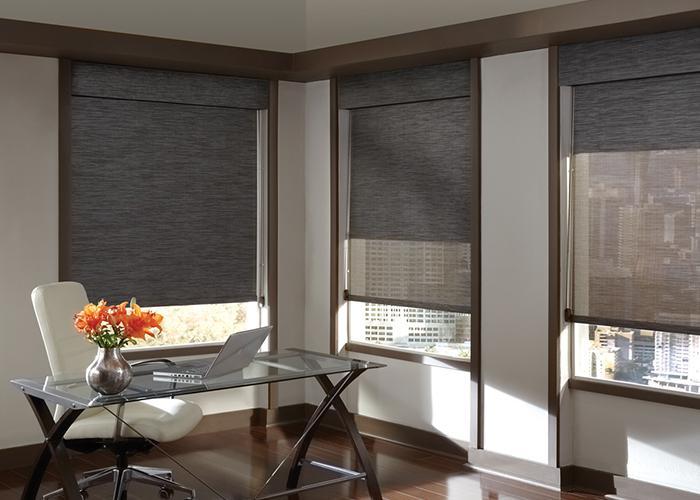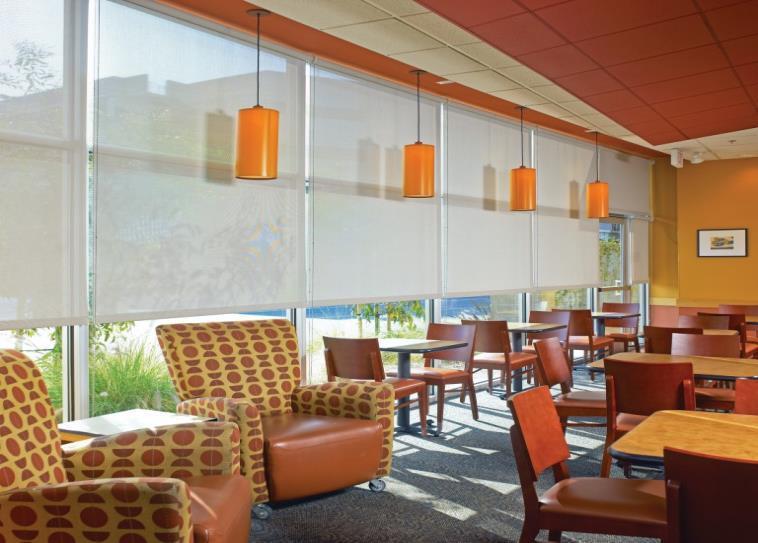The first image is the image on the left, the second image is the image on the right. Assess this claim about the two images: "An image shows an office space with a wall of square-paned window in front of work-stations.". Correct or not? Answer yes or no. No. 